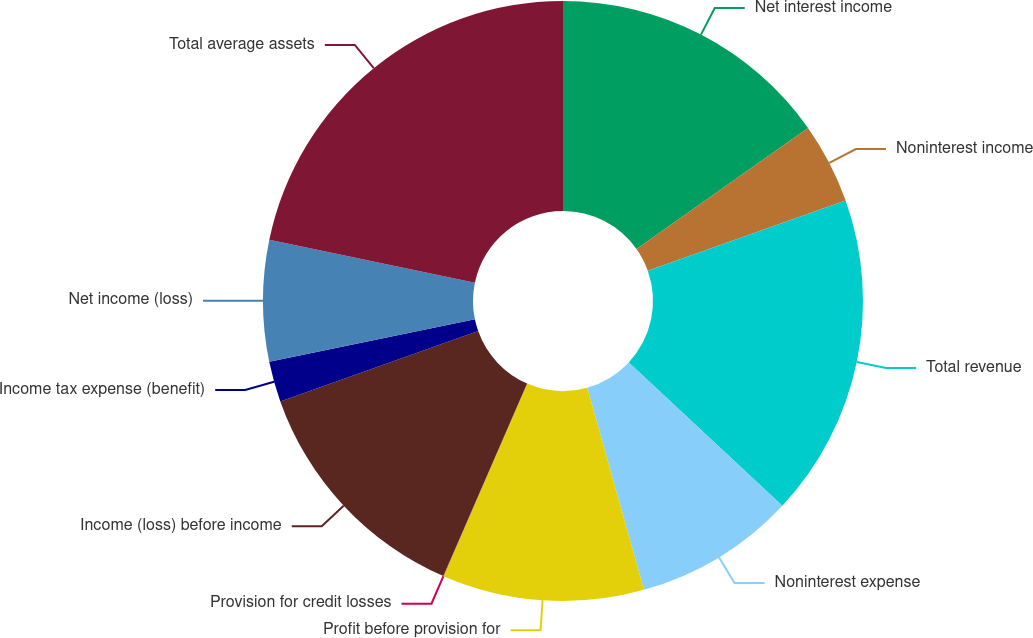Convert chart. <chart><loc_0><loc_0><loc_500><loc_500><pie_chart><fcel>Net interest income<fcel>Noninterest income<fcel>Total revenue<fcel>Noninterest expense<fcel>Profit before provision for<fcel>Provision for credit losses<fcel>Income (loss) before income<fcel>Income tax expense (benefit)<fcel>Net income (loss)<fcel>Total average assets<nl><fcel>15.21%<fcel>4.35%<fcel>17.39%<fcel>8.7%<fcel>10.87%<fcel>0.01%<fcel>13.04%<fcel>2.18%<fcel>6.52%<fcel>21.73%<nl></chart> 